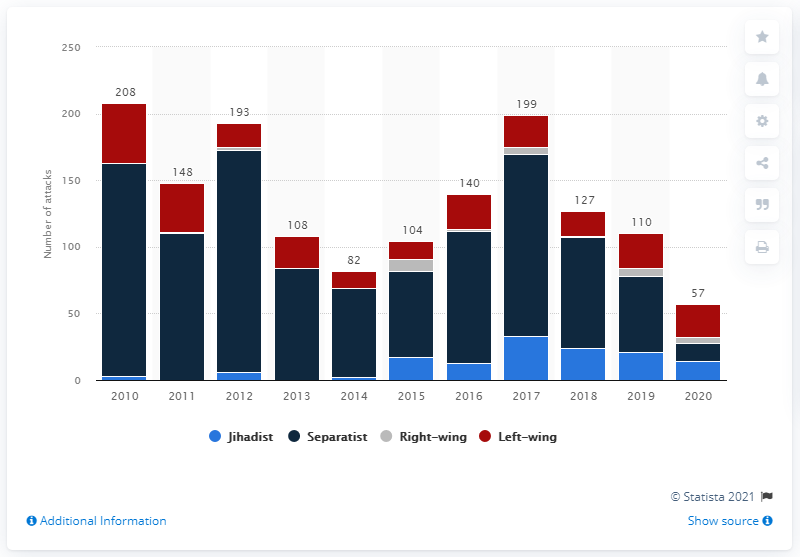Outline some significant characteristics in this image. There were 57 failed, foiled, or completed terrorist attacks in the European Union in 2020. 